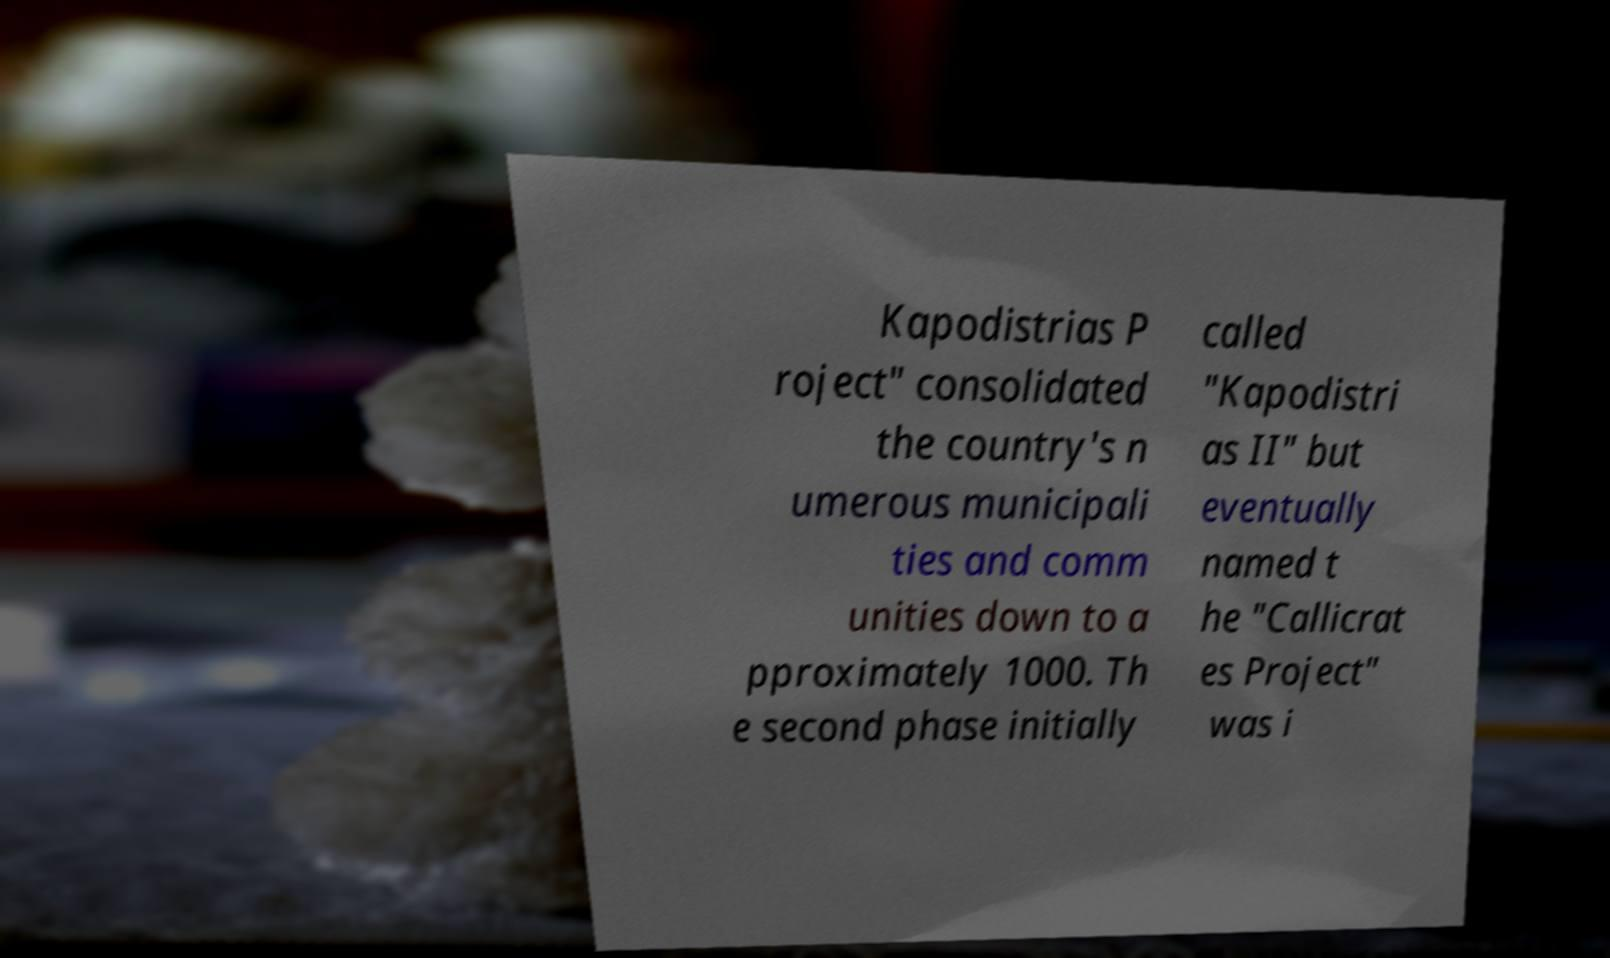Please identify and transcribe the text found in this image. Kapodistrias P roject" consolidated the country's n umerous municipali ties and comm unities down to a pproximately 1000. Th e second phase initially called "Kapodistri as II" but eventually named t he "Callicrat es Project" was i 